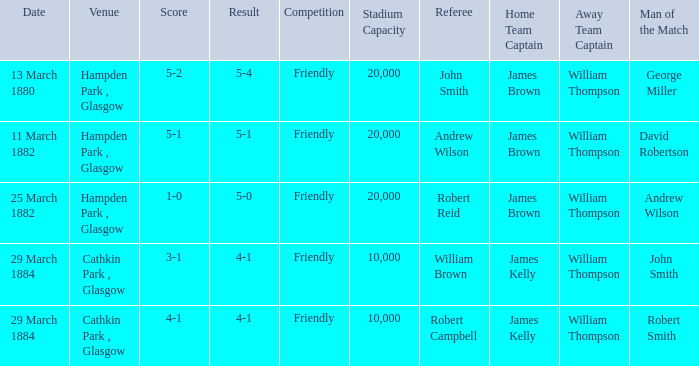Which competition had a 4-1 result, and a score of 4-1? Friendly. Could you help me parse every detail presented in this table? {'header': ['Date', 'Venue', 'Score', 'Result', 'Competition', 'Stadium Capacity', 'Referee', 'Home Team Captain', 'Away Team Captain', 'Man of the Match'], 'rows': [['13 March 1880', 'Hampden Park , Glasgow', '5-2', '5-4', 'Friendly', '20,000', 'John Smith', 'James Brown', 'William Thompson', 'George Miller'], ['11 March 1882', 'Hampden Park , Glasgow', '5-1', '5-1', 'Friendly', '20,000', 'Andrew Wilson', 'James Brown', 'William Thompson', 'David Robertson'], ['25 March 1882', 'Hampden Park , Glasgow', '1-0', '5-0', 'Friendly', '20,000', 'Robert Reid', 'James Brown', 'William Thompson', 'Andrew Wilson'], ['29 March 1884', 'Cathkin Park , Glasgow', '3-1', '4-1', 'Friendly', '10,000', 'William Brown', 'James Kelly', 'William Thompson', 'John Smith'], ['29 March 1884', 'Cathkin Park , Glasgow', '4-1', '4-1', 'Friendly', '10,000', 'Robert Campbell', 'James Kelly', 'William Thompson', 'Robert Smith']]} 